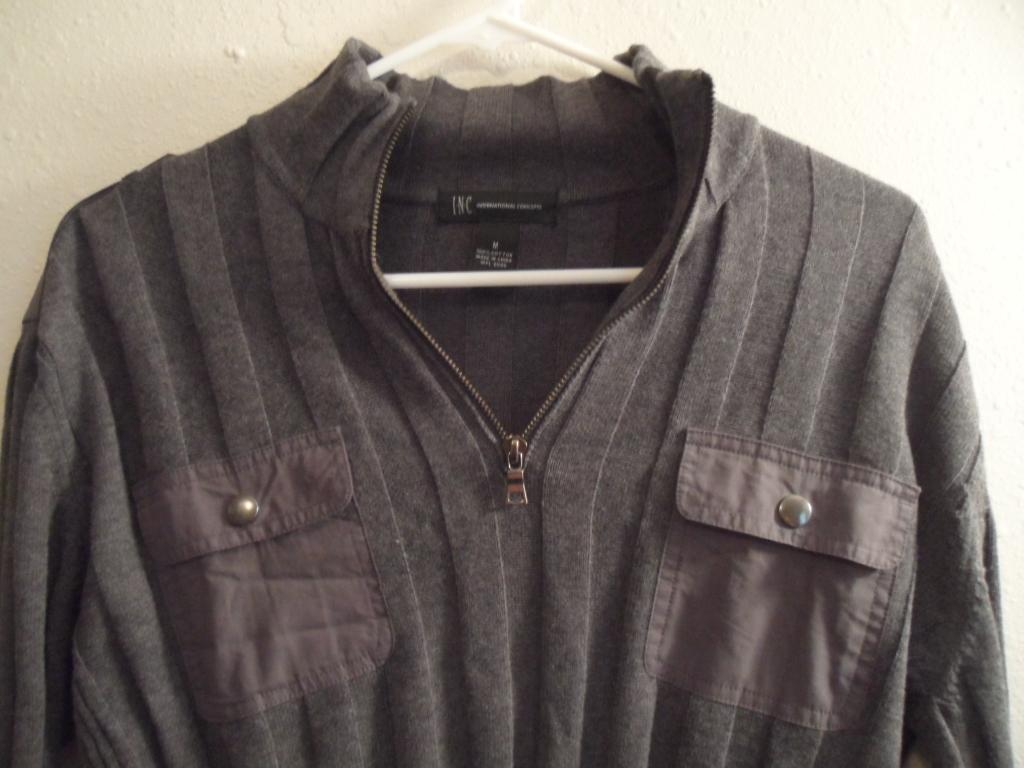What is hanging on the hanger in the image? There is a jacket on a hanger in the image. What can be seen in the background of the image? There is a wall visible in the background of the image. What type of insurance policy is mentioned on the wall in the image? There is no mention of any insurance policy on the wall in the image. Can you see a toothbrush hanging on the wall in the image? There is no toothbrush visible on the wall in the image. 